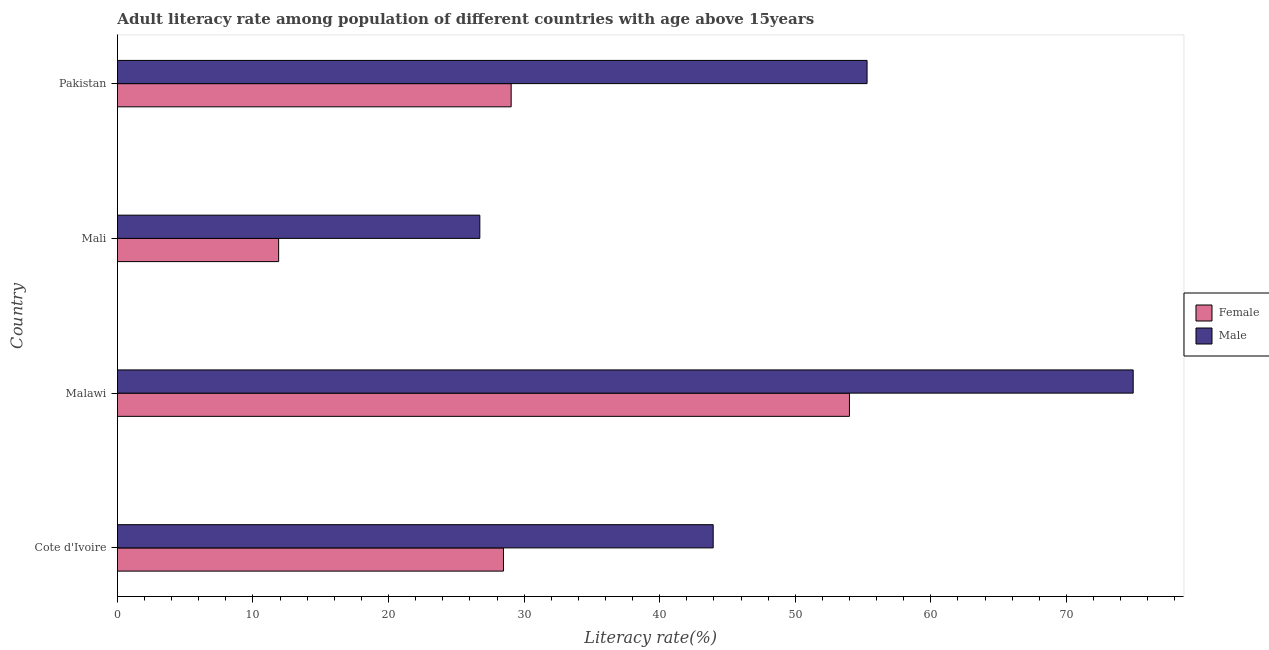Are the number of bars on each tick of the Y-axis equal?
Give a very brief answer. Yes. What is the label of the 4th group of bars from the top?
Ensure brevity in your answer.  Cote d'Ivoire. In how many cases, is the number of bars for a given country not equal to the number of legend labels?
Offer a terse response. 0. What is the male adult literacy rate in Cote d'Ivoire?
Offer a terse response. 43.95. Across all countries, what is the maximum male adult literacy rate?
Your answer should be compact. 74.93. Across all countries, what is the minimum male adult literacy rate?
Provide a short and direct response. 26.73. In which country was the female adult literacy rate maximum?
Provide a succinct answer. Malawi. In which country was the male adult literacy rate minimum?
Your response must be concise. Mali. What is the total female adult literacy rate in the graph?
Provide a short and direct response. 123.41. What is the difference between the male adult literacy rate in Malawi and that in Pakistan?
Keep it short and to the point. 19.63. What is the difference between the female adult literacy rate in Cote d'Ivoire and the male adult literacy rate in Malawi?
Ensure brevity in your answer.  -46.45. What is the average male adult literacy rate per country?
Your answer should be very brief. 50.23. What is the difference between the female adult literacy rate and male adult literacy rate in Cote d'Ivoire?
Offer a very short reply. -15.47. What is the ratio of the male adult literacy rate in Cote d'Ivoire to that in Pakistan?
Your answer should be very brief. 0.8. Is the female adult literacy rate in Malawi less than that in Pakistan?
Provide a short and direct response. No. Is the difference between the male adult literacy rate in Mali and Pakistan greater than the difference between the female adult literacy rate in Mali and Pakistan?
Provide a short and direct response. No. What is the difference between the highest and the second highest female adult literacy rate?
Offer a terse response. 24.95. What is the difference between the highest and the lowest female adult literacy rate?
Make the answer very short. 42.1. In how many countries, is the female adult literacy rate greater than the average female adult literacy rate taken over all countries?
Your answer should be compact. 1. How many countries are there in the graph?
Give a very brief answer. 4. What is the difference between two consecutive major ticks on the X-axis?
Ensure brevity in your answer.  10. Are the values on the major ticks of X-axis written in scientific E-notation?
Make the answer very short. No. Does the graph contain grids?
Provide a short and direct response. No. How are the legend labels stacked?
Offer a terse response. Vertical. What is the title of the graph?
Keep it short and to the point. Adult literacy rate among population of different countries with age above 15years. Does "Lowest 10% of population" appear as one of the legend labels in the graph?
Provide a succinct answer. No. What is the label or title of the X-axis?
Make the answer very short. Literacy rate(%). What is the label or title of the Y-axis?
Keep it short and to the point. Country. What is the Literacy rate(%) of Female in Cote d'Ivoire?
Provide a succinct answer. 28.48. What is the Literacy rate(%) in Male in Cote d'Ivoire?
Your answer should be compact. 43.95. What is the Literacy rate(%) in Female in Malawi?
Keep it short and to the point. 54. What is the Literacy rate(%) in Male in Malawi?
Ensure brevity in your answer.  74.93. What is the Literacy rate(%) of Female in Mali?
Make the answer very short. 11.89. What is the Literacy rate(%) of Male in Mali?
Provide a succinct answer. 26.73. What is the Literacy rate(%) of Female in Pakistan?
Give a very brief answer. 29.04. What is the Literacy rate(%) in Male in Pakistan?
Provide a short and direct response. 55.3. Across all countries, what is the maximum Literacy rate(%) of Female?
Give a very brief answer. 54. Across all countries, what is the maximum Literacy rate(%) in Male?
Provide a succinct answer. 74.93. Across all countries, what is the minimum Literacy rate(%) of Female?
Provide a short and direct response. 11.89. Across all countries, what is the minimum Literacy rate(%) of Male?
Your answer should be very brief. 26.73. What is the total Literacy rate(%) of Female in the graph?
Your answer should be very brief. 123.41. What is the total Literacy rate(%) of Male in the graph?
Provide a succinct answer. 200.9. What is the difference between the Literacy rate(%) of Female in Cote d'Ivoire and that in Malawi?
Keep it short and to the point. -25.52. What is the difference between the Literacy rate(%) of Male in Cote d'Ivoire and that in Malawi?
Your response must be concise. -30.98. What is the difference between the Literacy rate(%) of Female in Cote d'Ivoire and that in Mali?
Make the answer very short. 16.58. What is the difference between the Literacy rate(%) in Male in Cote d'Ivoire and that in Mali?
Your answer should be very brief. 17.21. What is the difference between the Literacy rate(%) of Female in Cote d'Ivoire and that in Pakistan?
Ensure brevity in your answer.  -0.57. What is the difference between the Literacy rate(%) in Male in Cote d'Ivoire and that in Pakistan?
Provide a short and direct response. -11.35. What is the difference between the Literacy rate(%) of Female in Malawi and that in Mali?
Your answer should be very brief. 42.1. What is the difference between the Literacy rate(%) in Male in Malawi and that in Mali?
Your answer should be very brief. 48.19. What is the difference between the Literacy rate(%) in Female in Malawi and that in Pakistan?
Provide a short and direct response. 24.95. What is the difference between the Literacy rate(%) in Male in Malawi and that in Pakistan?
Ensure brevity in your answer.  19.63. What is the difference between the Literacy rate(%) in Female in Mali and that in Pakistan?
Make the answer very short. -17.15. What is the difference between the Literacy rate(%) of Male in Mali and that in Pakistan?
Your answer should be very brief. -28.56. What is the difference between the Literacy rate(%) of Female in Cote d'Ivoire and the Literacy rate(%) of Male in Malawi?
Provide a short and direct response. -46.45. What is the difference between the Literacy rate(%) of Female in Cote d'Ivoire and the Literacy rate(%) of Male in Mali?
Give a very brief answer. 1.74. What is the difference between the Literacy rate(%) in Female in Cote d'Ivoire and the Literacy rate(%) in Male in Pakistan?
Give a very brief answer. -26.82. What is the difference between the Literacy rate(%) of Female in Malawi and the Literacy rate(%) of Male in Mali?
Ensure brevity in your answer.  27.26. What is the difference between the Literacy rate(%) of Female in Malawi and the Literacy rate(%) of Male in Pakistan?
Offer a very short reply. -1.3. What is the difference between the Literacy rate(%) of Female in Mali and the Literacy rate(%) of Male in Pakistan?
Ensure brevity in your answer.  -43.4. What is the average Literacy rate(%) in Female per country?
Keep it short and to the point. 30.85. What is the average Literacy rate(%) of Male per country?
Your answer should be compact. 50.23. What is the difference between the Literacy rate(%) of Female and Literacy rate(%) of Male in Cote d'Ivoire?
Your answer should be compact. -15.47. What is the difference between the Literacy rate(%) of Female and Literacy rate(%) of Male in Malawi?
Make the answer very short. -20.93. What is the difference between the Literacy rate(%) of Female and Literacy rate(%) of Male in Mali?
Offer a very short reply. -14.84. What is the difference between the Literacy rate(%) in Female and Literacy rate(%) in Male in Pakistan?
Provide a succinct answer. -26.25. What is the ratio of the Literacy rate(%) in Female in Cote d'Ivoire to that in Malawi?
Your response must be concise. 0.53. What is the ratio of the Literacy rate(%) in Male in Cote d'Ivoire to that in Malawi?
Provide a short and direct response. 0.59. What is the ratio of the Literacy rate(%) in Female in Cote d'Ivoire to that in Mali?
Offer a very short reply. 2.39. What is the ratio of the Literacy rate(%) of Male in Cote d'Ivoire to that in Mali?
Your answer should be very brief. 1.64. What is the ratio of the Literacy rate(%) of Female in Cote d'Ivoire to that in Pakistan?
Provide a succinct answer. 0.98. What is the ratio of the Literacy rate(%) of Male in Cote d'Ivoire to that in Pakistan?
Offer a terse response. 0.79. What is the ratio of the Literacy rate(%) in Female in Malawi to that in Mali?
Offer a very short reply. 4.54. What is the ratio of the Literacy rate(%) in Male in Malawi to that in Mali?
Offer a terse response. 2.8. What is the ratio of the Literacy rate(%) in Female in Malawi to that in Pakistan?
Your answer should be very brief. 1.86. What is the ratio of the Literacy rate(%) in Male in Malawi to that in Pakistan?
Give a very brief answer. 1.35. What is the ratio of the Literacy rate(%) in Female in Mali to that in Pakistan?
Make the answer very short. 0.41. What is the ratio of the Literacy rate(%) in Male in Mali to that in Pakistan?
Give a very brief answer. 0.48. What is the difference between the highest and the second highest Literacy rate(%) in Female?
Provide a succinct answer. 24.95. What is the difference between the highest and the second highest Literacy rate(%) of Male?
Give a very brief answer. 19.63. What is the difference between the highest and the lowest Literacy rate(%) in Female?
Keep it short and to the point. 42.1. What is the difference between the highest and the lowest Literacy rate(%) of Male?
Ensure brevity in your answer.  48.19. 